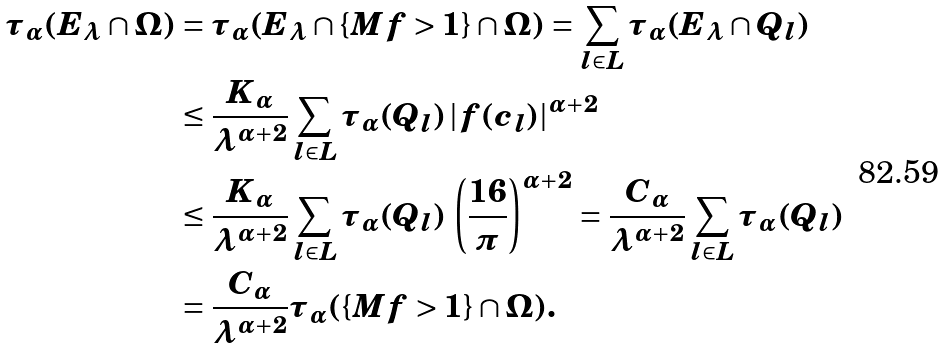Convert formula to latex. <formula><loc_0><loc_0><loc_500><loc_500>\tau _ { \alpha } ( E _ { \lambda } \cap \Omega ) & = \tau _ { \alpha } ( E _ { \lambda } \cap \{ M f > 1 \} \cap \Omega ) = \sum _ { l \in L } \tau _ { \alpha } ( E _ { \lambda } \cap Q _ { l } ) \\ & \leq \frac { K _ { \alpha } } { \lambda ^ { \alpha + 2 } } \sum _ { l \in L } \tau _ { \alpha } ( Q _ { l } ) \, | f ( c _ { l } ) | ^ { \alpha + 2 } \\ & \leq \frac { K _ { \alpha } } { \lambda ^ { \alpha + 2 } } \sum _ { l \in L } \tau _ { \alpha } ( Q _ { l } ) \, \left ( \frac { 1 6 } { \pi } \right ) ^ { \alpha + 2 } = \frac { C _ { \alpha } } { \lambda ^ { \alpha + 2 } } \sum _ { l \in L } \tau _ { \alpha } ( Q _ { l } ) \\ & = \frac { C _ { \alpha } } { \lambda ^ { \alpha + 2 } } \tau _ { \alpha } ( \{ M f > 1 \} \cap \Omega ) .</formula> 